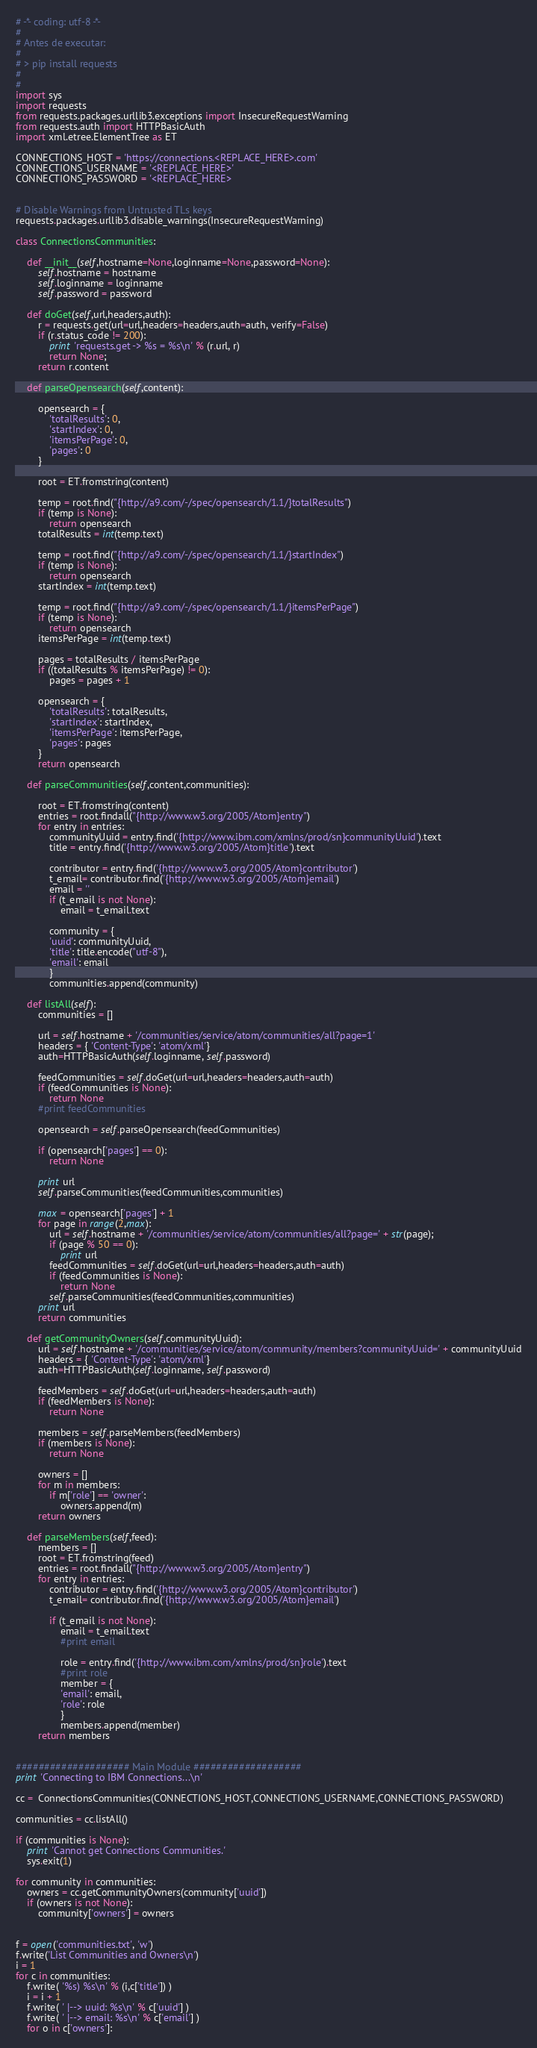Convert code to text. <code><loc_0><loc_0><loc_500><loc_500><_Python_># -*- coding: utf-8 -*-
#
# Antes de executar:
#
# > pip install requests
#
#
import sys
import requests
from requests.packages.urllib3.exceptions import InsecureRequestWarning
from requests.auth import HTTPBasicAuth
import xml.etree.ElementTree as ET

CONNECTIONS_HOST = 'https://connections.<REPLACE_HERE>.com'
CONNECTIONS_USERNAME = '<REPLACE_HERE>'
CONNECTIONS_PASSWORD = '<REPLACE_HERE>


# Disable Warnings from Untrusted TLs keys
requests.packages.urllib3.disable_warnings(InsecureRequestWarning)

class ConnectionsCommunities:

    def __init__(self,hostname=None,loginname=None,password=None):
        self.hostname = hostname
        self.loginname = loginname
        self.password = password

    def doGet(self,url,headers,auth):
        r = requests.get(url=url,headers=headers,auth=auth, verify=False)
        if (r.status_code != 200):
            print 'requests.get -> %s = %s\n' % (r.url, r)
            return None;
        return r.content

    def parseOpensearch(self,content):

        opensearch = {
            'totalResults': 0,
            'startIndex': 0,
            'itemsPerPage': 0,
            'pages': 0
        }

        root = ET.fromstring(content)

        temp = root.find("{http://a9.com/-/spec/opensearch/1.1/}totalResults")
        if (temp is None):
            return opensearch
        totalResults = int(temp.text)

        temp = root.find("{http://a9.com/-/spec/opensearch/1.1/}startIndex")
        if (temp is None):
            return opensearch
        startIndex = int(temp.text)

        temp = root.find("{http://a9.com/-/spec/opensearch/1.1/}itemsPerPage")
        if (temp is None):
            return opensearch
        itemsPerPage = int(temp.text)

        pages = totalResults / itemsPerPage
        if ((totalResults % itemsPerPage) != 0):
            pages = pages + 1

        opensearch = {
            'totalResults': totalResults,
            'startIndex': startIndex,
            'itemsPerPage': itemsPerPage,
            'pages': pages
        }
        return opensearch

    def parseCommunities(self,content,communities):

        root = ET.fromstring(content)
        entries = root.findall("{http://www.w3.org/2005/Atom}entry")
        for entry in entries:
            communityUuid = entry.find('{http://www.ibm.com/xmlns/prod/sn}communityUuid').text
            title = entry.find('{http://www.w3.org/2005/Atom}title').text

            contributor = entry.find('{http://www.w3.org/2005/Atom}contributor')
            t_email= contributor.find('{http://www.w3.org/2005/Atom}email')
            email = ''
            if (t_email is not None):
                email = t_email.text

            community = {
            'uuid': communityUuid,
            'title': title.encode("utf-8"),
            'email': email
            }
            communities.append(community)

    def listAll(self):
        communities = []

        url = self.hostname + '/communities/service/atom/communities/all?page=1'
        headers = { 'Content-Type': 'atom/xml'}
        auth=HTTPBasicAuth(self.loginname, self.password)

        feedCommunities = self.doGet(url=url,headers=headers,auth=auth)
        if (feedCommunities is None):
            return None
        #print feedCommunities

        opensearch = self.parseOpensearch(feedCommunities)

        if (opensearch['pages'] == 0):
            return None

        print url
        self.parseCommunities(feedCommunities,communities)
    
        max = opensearch['pages'] + 1
        for page in range(2,max):
            url = self.hostname + '/communities/service/atom/communities/all?page=' + str(page);
            if (page % 50 == 0):
                print url
            feedCommunities = self.doGet(url=url,headers=headers,auth=auth)
            if (feedCommunities is None):
                return None
            self.parseCommunities(feedCommunities,communities)
        print url
        return communities

    def getCommunityOwners(self,communityUuid):
        url = self.hostname + '/communities/service/atom/community/members?communityUuid=' + communityUuid
        headers = { 'Content-Type': 'atom/xml'}
        auth=HTTPBasicAuth(self.loginname, self.password)

        feedMembers = self.doGet(url=url,headers=headers,auth=auth)
        if (feedMembers is None):
            return None

        members = self.parseMembers(feedMembers)
        if (members is None):
            return None

        owners = []
        for m in members:
            if m['role'] == 'owner':
                owners.append(m)
        return owners

    def parseMembers(self,feed):
        members = []
        root = ET.fromstring(feed)
        entries = root.findall("{http://www.w3.org/2005/Atom}entry")
        for entry in entries:
            contributor = entry.find('{http://www.w3.org/2005/Atom}contributor')
            t_email= contributor.find('{http://www.w3.org/2005/Atom}email')

            if (t_email is not None):
                email = t_email.text
                #print email

                role = entry.find('{http://www.ibm.com/xmlns/prod/sn}role').text
                #print role
                member = {
                'email': email,
                'role': role
                }
                members.append(member)
        return members


#################### Main Module ###################
print 'Connecting to IBM Connections...\n'

cc =  ConnectionsCommunities(CONNECTIONS_HOST,CONNECTIONS_USERNAME,CONNECTIONS_PASSWORD)

communities = cc.listAll()

if (communities is None):
    print 'Cannot get Connections Communities.'
    sys.exit(1)

for community in communities:
    owners = cc.getCommunityOwners(community['uuid'])
    if (owners is not None):
        community['owners'] = owners


f = open('communities.txt', 'w')
f.write('List Communities and Owners\n')
i = 1
for c in communities:
    f.write( '%s) %s\n' % (i,c['title']) )
    i = i + 1
    f.write( ' |--> uuid: %s\n' % c['uuid'] )
    f.write( ' |--> email: %s\n' % c['email'] )
    for o in c['owners']:</code> 